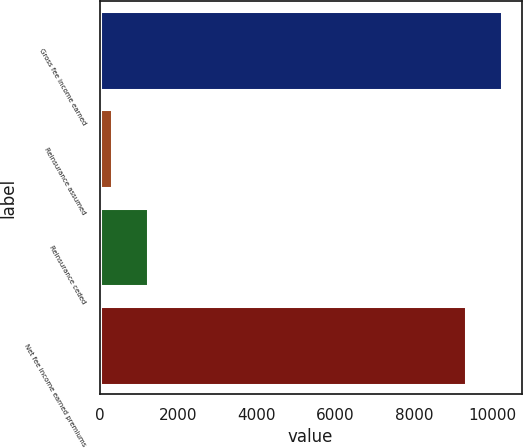Convert chart. <chart><loc_0><loc_0><loc_500><loc_500><bar_chart><fcel>Gross fee income earned<fcel>Reinsurance assumed<fcel>Reinsurance ceded<fcel>Net fee income earned premiums<nl><fcel>10221.9<fcel>313<fcel>1218.9<fcel>9316<nl></chart> 